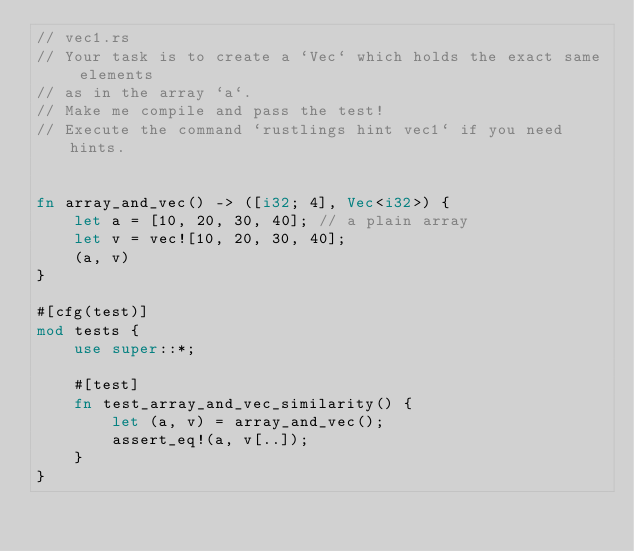<code> <loc_0><loc_0><loc_500><loc_500><_Rust_>// vec1.rs
// Your task is to create a `Vec` which holds the exact same elements
// as in the array `a`.
// Make me compile and pass the test!
// Execute the command `rustlings hint vec1` if you need hints.


fn array_and_vec() -> ([i32; 4], Vec<i32>) {
    let a = [10, 20, 30, 40]; // a plain array
    let v = vec![10, 20, 30, 40];
    (a, v)
}

#[cfg(test)]
mod tests {
    use super::*;

    #[test]
    fn test_array_and_vec_similarity() {
        let (a, v) = array_and_vec();
        assert_eq!(a, v[..]);
    }
}
</code> 